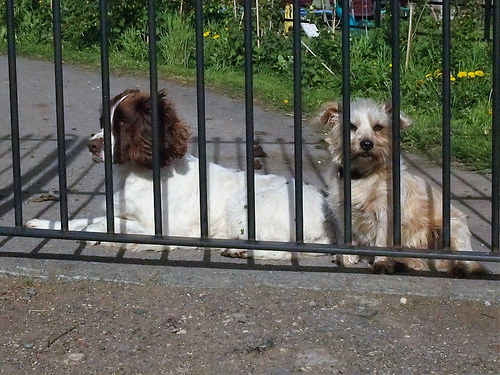<image>
Can you confirm if the dog is to the right of the dog? Yes. From this viewpoint, the dog is positioned to the right side relative to the dog. Is the fence behind the dog? No. The fence is not behind the dog. From this viewpoint, the fence appears to be positioned elsewhere in the scene. 